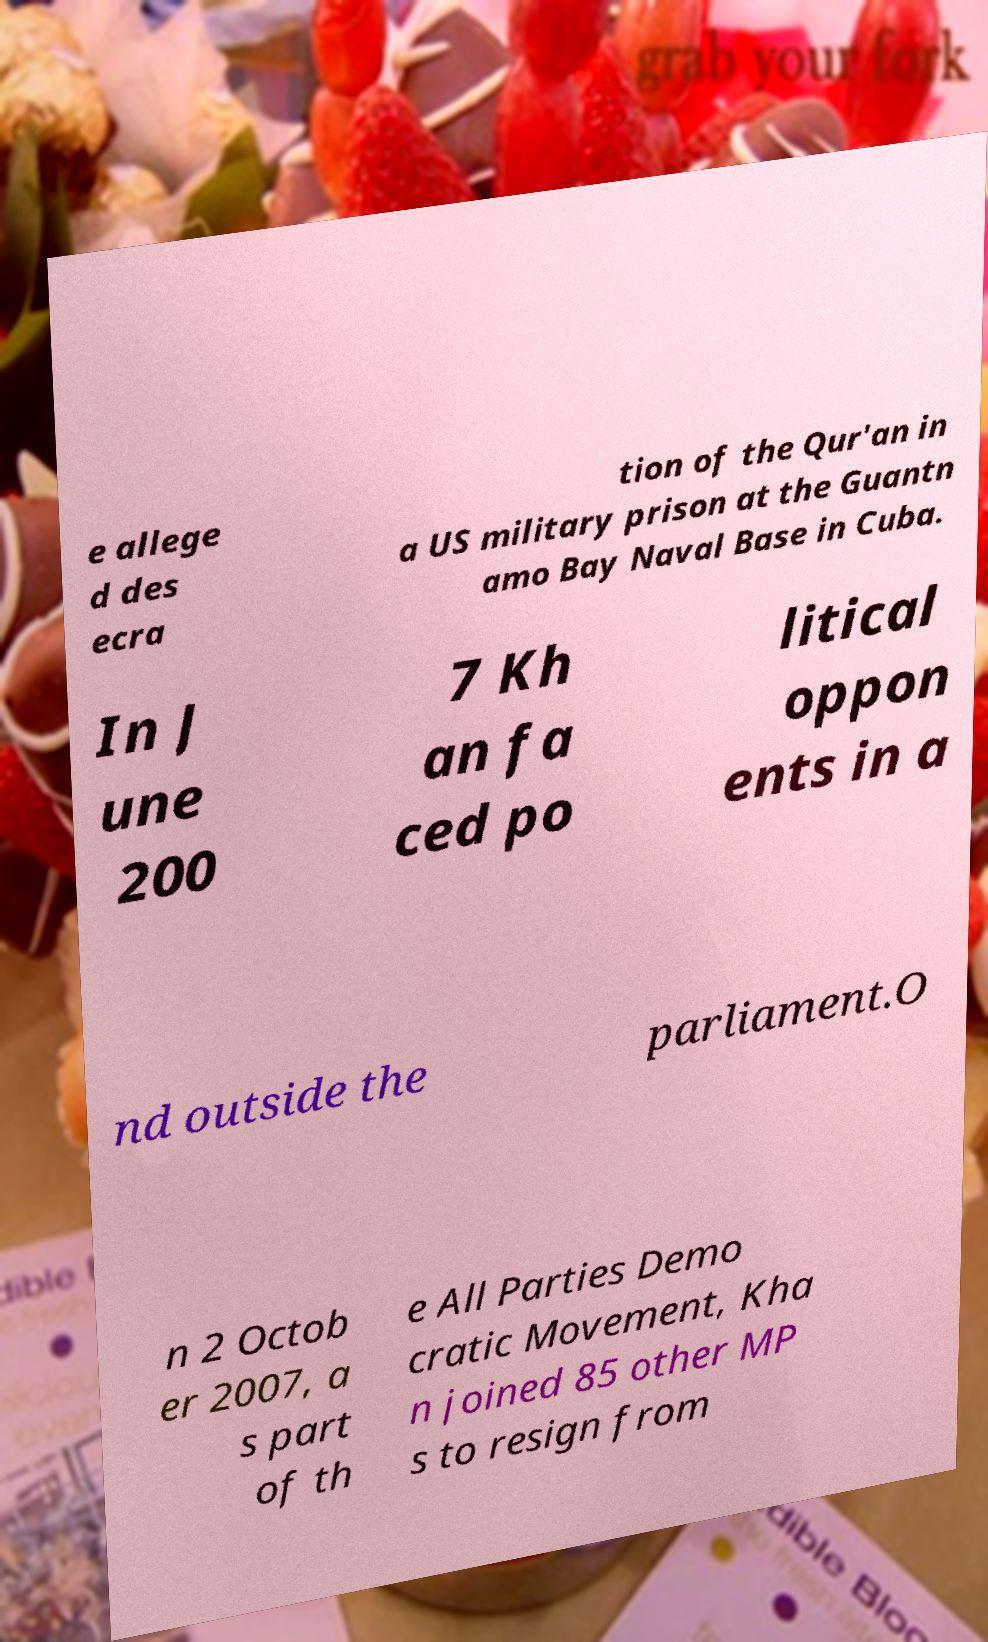Can you read and provide the text displayed in the image?This photo seems to have some interesting text. Can you extract and type it out for me? e allege d des ecra tion of the Qur'an in a US military prison at the Guantn amo Bay Naval Base in Cuba. In J une 200 7 Kh an fa ced po litical oppon ents in a nd outside the parliament.O n 2 Octob er 2007, a s part of th e All Parties Demo cratic Movement, Kha n joined 85 other MP s to resign from 